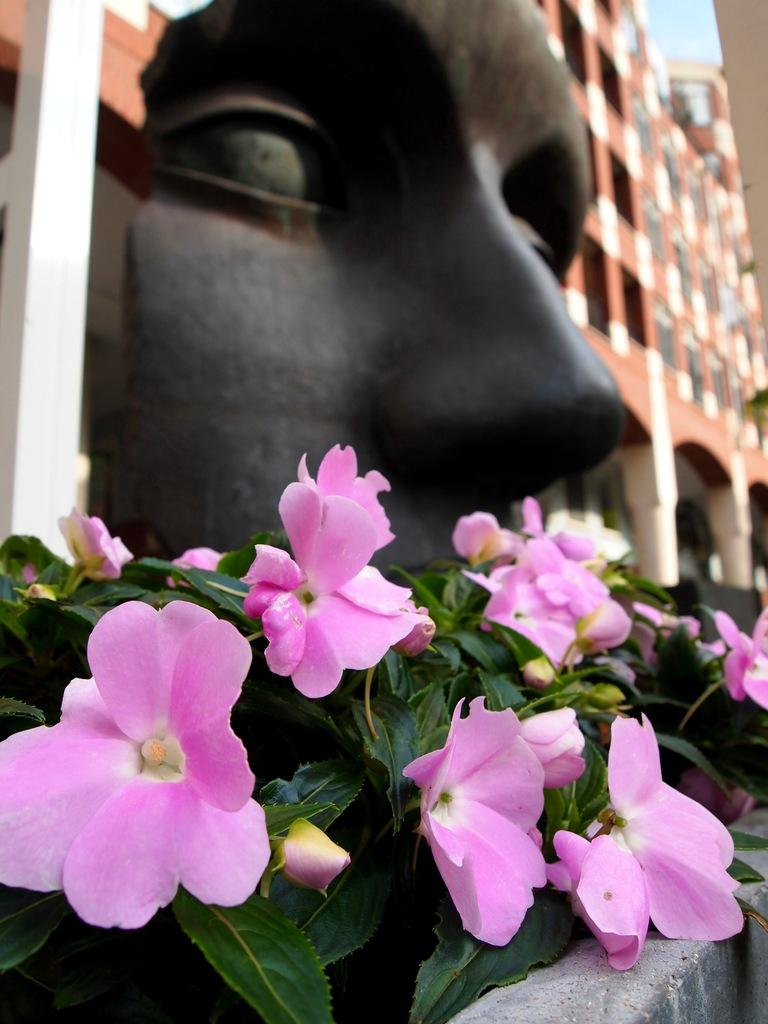What type of structure is visible in the image? There is a building in the image. What can be seen behind the building? There is a face sculpture behind the building. What type of vegetation is in front of the building? There are flower plants in front of the building. What type of glue is used to attach the stove to the building in the image? There is no stove present in the image, so it is not possible to determine what type of glue might be used. 